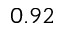<formula> <loc_0><loc_0><loc_500><loc_500>0 . 9 2</formula> 